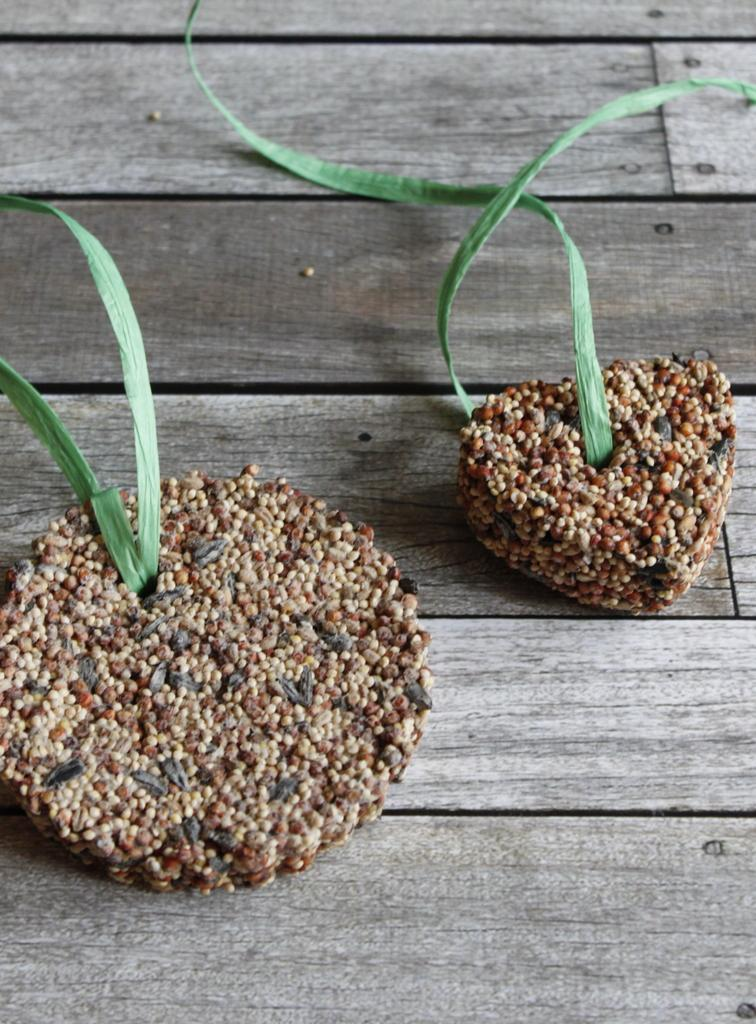What are the shapes of the two objects on the wooden surface? One object is in a round shape, and the other object is in a heart shape. What type of machine is visible on the wooden surface? There is no machine present on the wooden surface; only two objects with round and heart shapes are visible. 